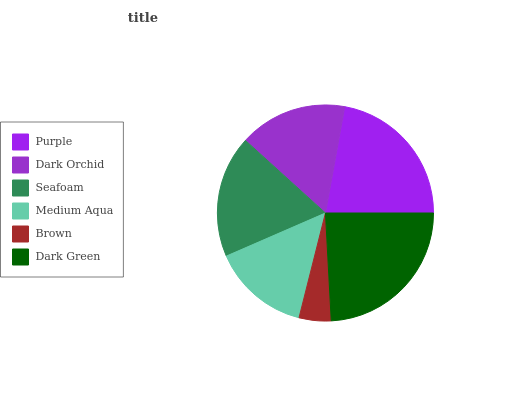Is Brown the minimum?
Answer yes or no. Yes. Is Dark Green the maximum?
Answer yes or no. Yes. Is Dark Orchid the minimum?
Answer yes or no. No. Is Dark Orchid the maximum?
Answer yes or no. No. Is Purple greater than Dark Orchid?
Answer yes or no. Yes. Is Dark Orchid less than Purple?
Answer yes or no. Yes. Is Dark Orchid greater than Purple?
Answer yes or no. No. Is Purple less than Dark Orchid?
Answer yes or no. No. Is Seafoam the high median?
Answer yes or no. Yes. Is Dark Orchid the low median?
Answer yes or no. Yes. Is Dark Green the high median?
Answer yes or no. No. Is Brown the low median?
Answer yes or no. No. 